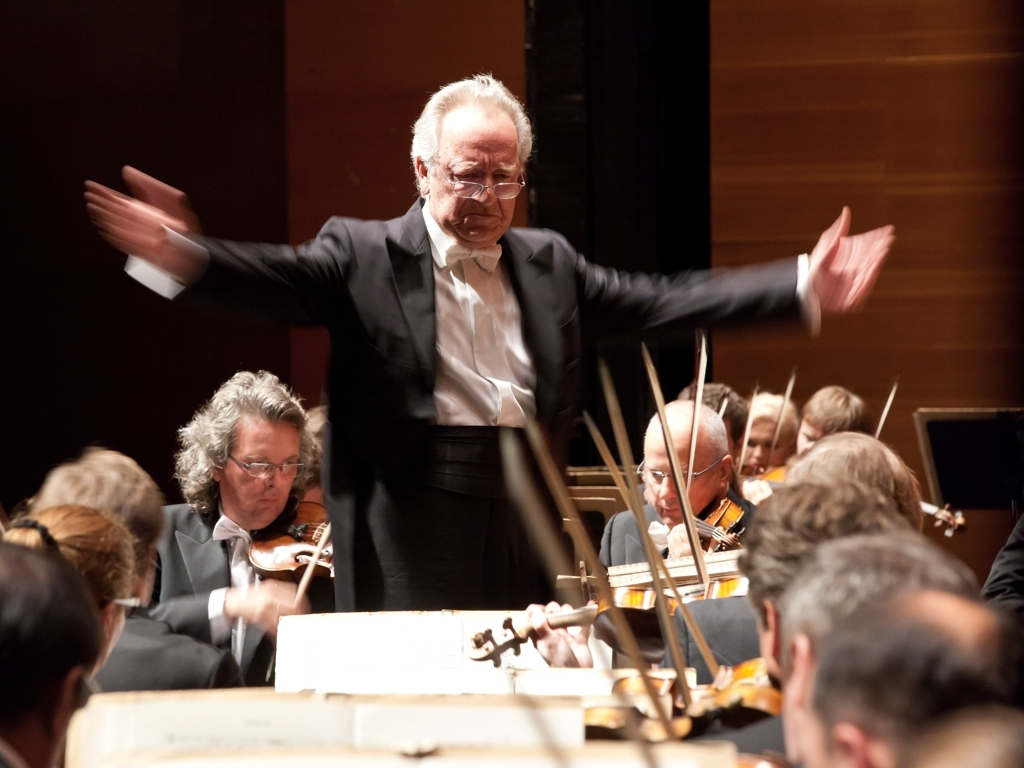Describe the composition of the orchestra as seen in the photograph. In the photograph, we see a segment of the orchestra featuring string musicians, with violinists in the foreground. The players are attentively following the conductor's lead, indicated by their focused gaze and poised instruments. The arrangement seems typical of a classical symphony orchestra, with the musicians seated in a semi-circle to better pick up on the conductor's cues and maintain cohesion in their performance. 